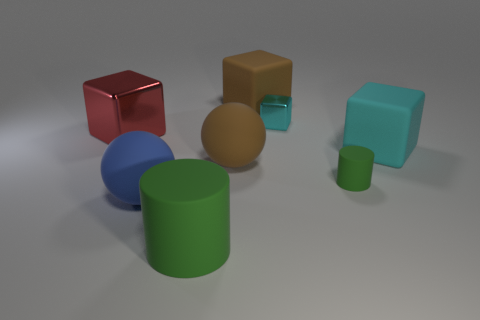Add 2 large cylinders. How many objects exist? 10 Subtract all cylinders. How many objects are left? 6 Add 8 brown spheres. How many brown spheres exist? 9 Subtract 1 red blocks. How many objects are left? 7 Subtract all small rubber cylinders. Subtract all small objects. How many objects are left? 5 Add 7 blue rubber spheres. How many blue rubber spheres are left? 8 